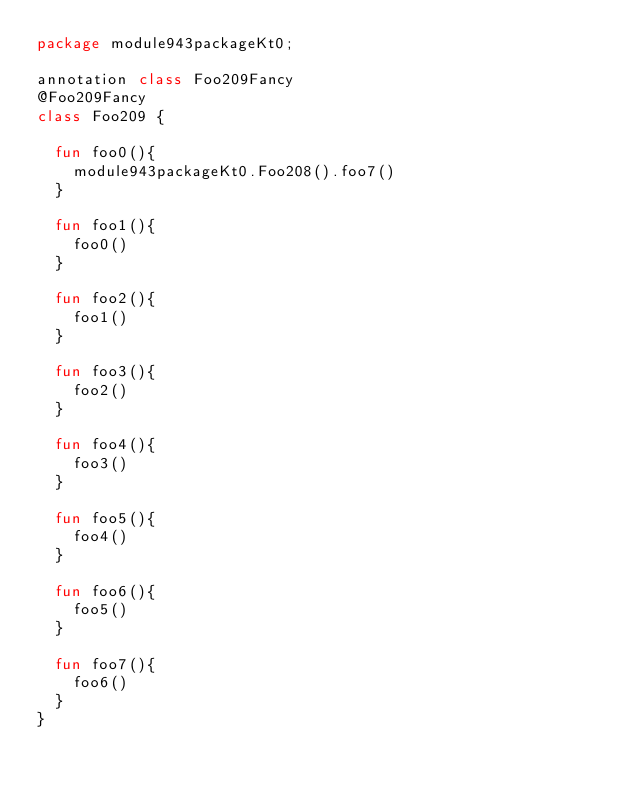<code> <loc_0><loc_0><loc_500><loc_500><_Kotlin_>package module943packageKt0;

annotation class Foo209Fancy
@Foo209Fancy
class Foo209 {

  fun foo0(){
    module943packageKt0.Foo208().foo7()
  }

  fun foo1(){
    foo0()
  }

  fun foo2(){
    foo1()
  }

  fun foo3(){
    foo2()
  }

  fun foo4(){
    foo3()
  }

  fun foo5(){
    foo4()
  }

  fun foo6(){
    foo5()
  }

  fun foo7(){
    foo6()
  }
}</code> 